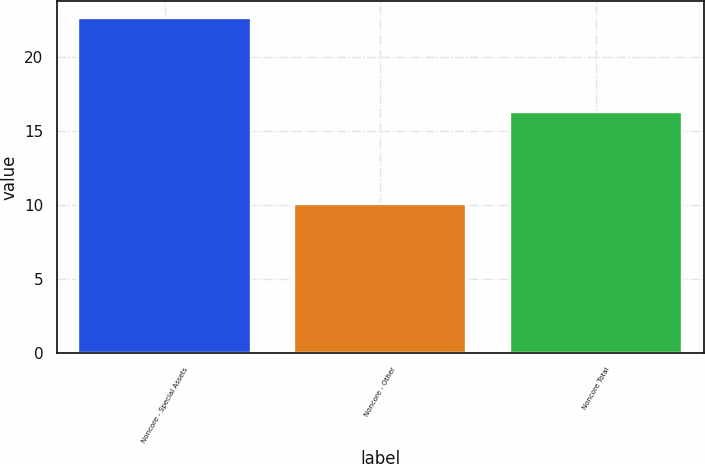<chart> <loc_0><loc_0><loc_500><loc_500><bar_chart><fcel>Noncore - Special Assets<fcel>Noncore - Other<fcel>Noncore Total<nl><fcel>22.66<fcel>10.1<fcel>16.32<nl></chart> 